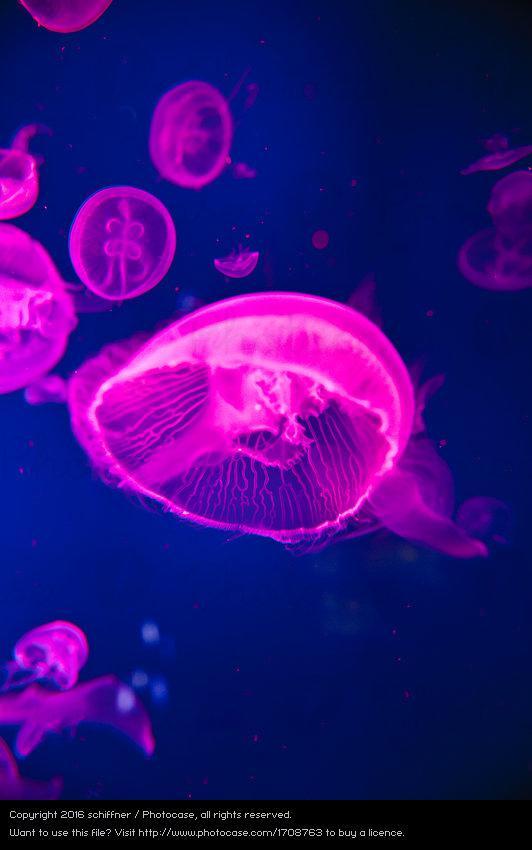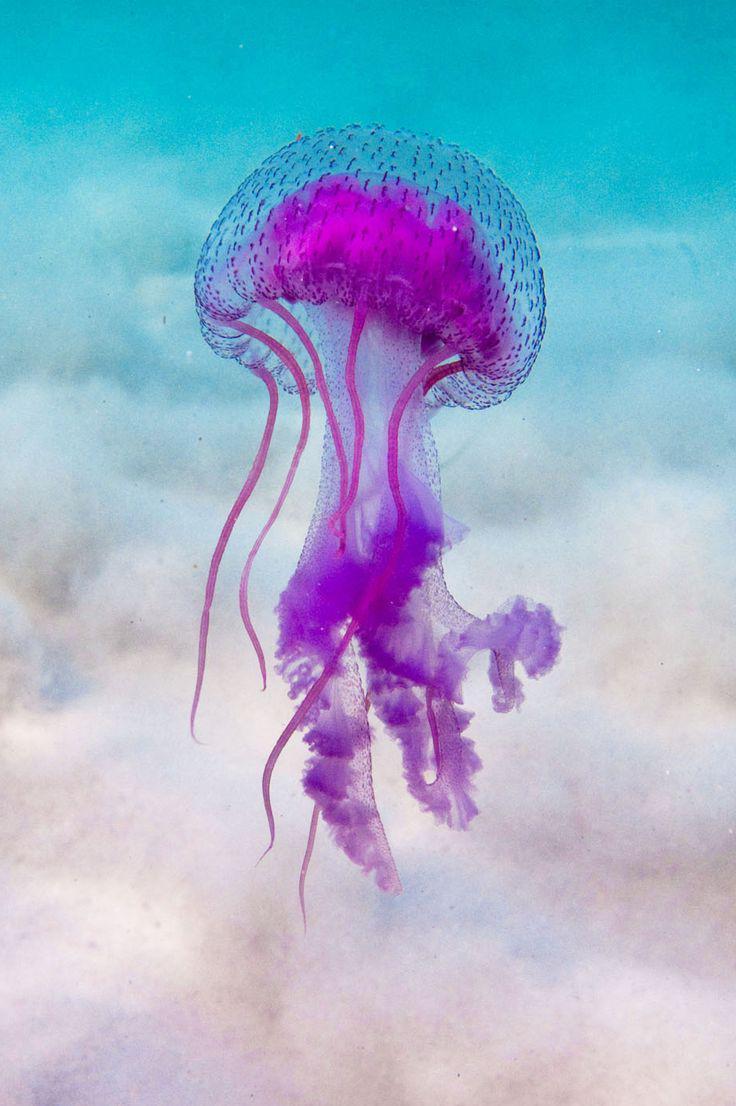The first image is the image on the left, the second image is the image on the right. Evaluate the accuracy of this statement regarding the images: "Left image shows multiple disk-shaped hot-pink jellyfish on a blue background.". Is it true? Answer yes or no. Yes. The first image is the image on the left, the second image is the image on the right. For the images shown, is this caption "There are multiple jellyfish in water in the right image." true? Answer yes or no. No. 